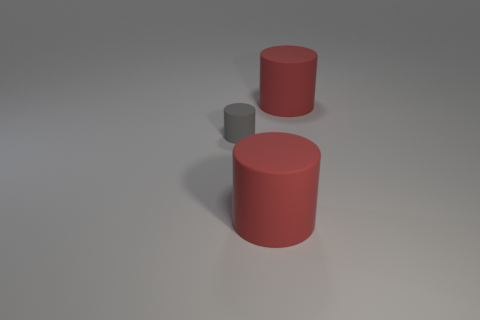How many matte objects are big things or gray objects?
Offer a very short reply. 3. The big object behind the small gray matte cylinder has what shape?
Make the answer very short. Cylinder. Does the big object that is behind the gray rubber cylinder have the same color as the small rubber cylinder?
Provide a short and direct response. No. There is a large red matte object that is behind the gray matte cylinder; does it have the same shape as the large red matte thing that is in front of the tiny matte object?
Provide a short and direct response. Yes. What size is the red rubber cylinder in front of the tiny gray thing?
Keep it short and to the point. Large. There is a red matte cylinder left of the red rubber object behind the gray thing; what is its size?
Your answer should be compact. Large. Are there more gray rubber things than cylinders?
Make the answer very short. No. What number of matte objects have the same size as the gray rubber cylinder?
Give a very brief answer. 0. There is a red object behind the small rubber cylinder; is it the same shape as the gray rubber thing?
Offer a very short reply. Yes. Is the number of things that are in front of the tiny gray thing less than the number of red matte things?
Keep it short and to the point. Yes. 